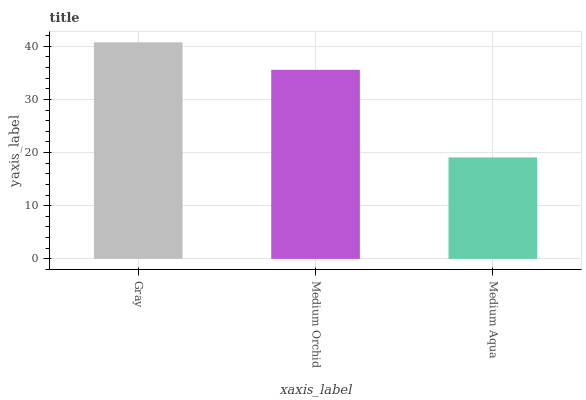Is Medium Orchid the minimum?
Answer yes or no. No. Is Medium Orchid the maximum?
Answer yes or no. No. Is Gray greater than Medium Orchid?
Answer yes or no. Yes. Is Medium Orchid less than Gray?
Answer yes or no. Yes. Is Medium Orchid greater than Gray?
Answer yes or no. No. Is Gray less than Medium Orchid?
Answer yes or no. No. Is Medium Orchid the high median?
Answer yes or no. Yes. Is Medium Orchid the low median?
Answer yes or no. Yes. Is Gray the high median?
Answer yes or no. No. Is Gray the low median?
Answer yes or no. No. 